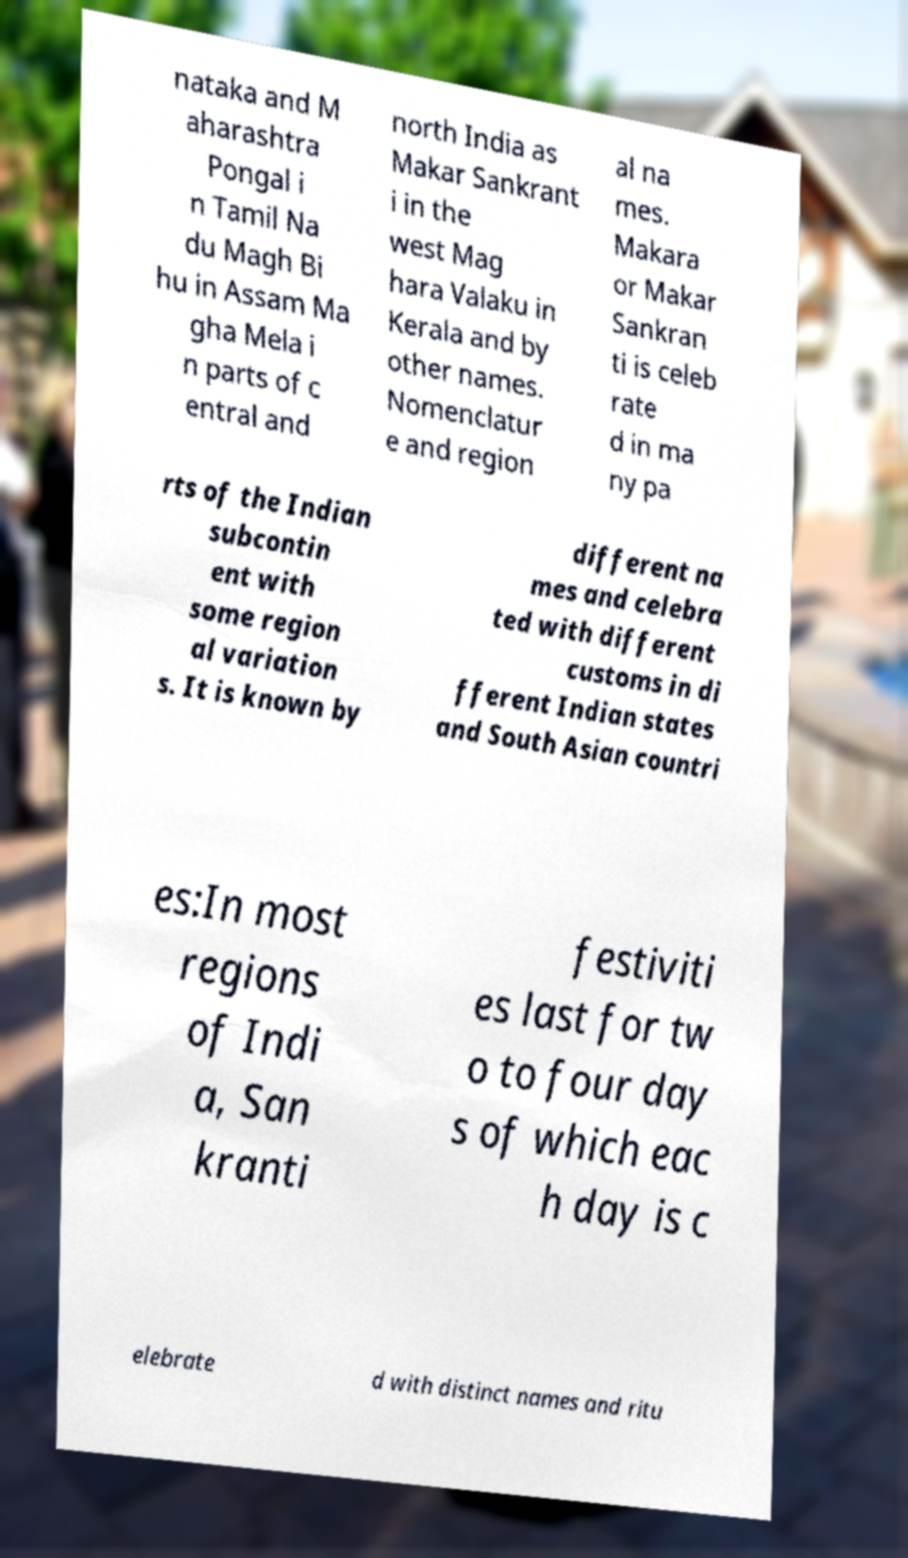Can you read and provide the text displayed in the image?This photo seems to have some interesting text. Can you extract and type it out for me? nataka and M aharashtra Pongal i n Tamil Na du Magh Bi hu in Assam Ma gha Mela i n parts of c entral and north India as Makar Sankrant i in the west Mag hara Valaku in Kerala and by other names. Nomenclatur e and region al na mes. Makara or Makar Sankran ti is celeb rate d in ma ny pa rts of the Indian subcontin ent with some region al variation s. It is known by different na mes and celebra ted with different customs in di fferent Indian states and South Asian countri es:In most regions of Indi a, San kranti festiviti es last for tw o to four day s of which eac h day is c elebrate d with distinct names and ritu 